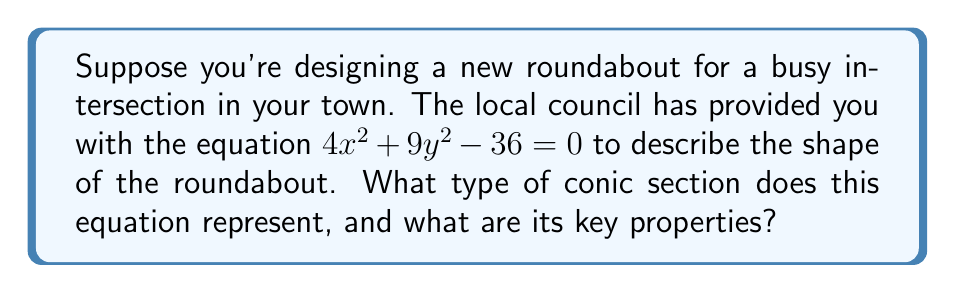Could you help me with this problem? Let's approach this step-by-step:

1) The general form of a conic section is:
   $Ax^2 + Bxy + Cy^2 + Dx + Ey + F = 0$

2) In our equation $4x^2 + 9y^2 - 36 = 0$, we can identify:
   $A = 4$, $C = 9$, $F = -36$, and $B = D = E = 0$

3) To determine the type of conic section, we need to look at the coefficients of $x^2$ and $y^2$:
   - Both coefficients are positive and non-zero
   - There's no $xy$ term (B = 0)
   - The constant term is on the other side of the equation

   These characteristics indicate that this is an ellipse.

4) To find the properties, let's rearrange the equation:
   $\frac{x^2}{9} + \frac{y^2}{4} = 1$

5) This is the standard form of an ellipse: $\frac{x^2}{a^2} + \frac{y^2}{b^2} = 1$
   Where $a$ and $b$ are the lengths of the semi-major and semi-minor axes.

6) From our equation:
   $a^2 = 9$, so $a = 3$
   $b^2 = 4$, so $b = 2$

7) Key properties:
   - Center: (0, 0)
   - Semi-major axis: 3 units (along x-axis)
   - Semi-minor axis: 2 units (along y-axis)
   - Eccentricity: $e = \sqrt{1 - \frac{b^2}{a^2}} = \sqrt{1 - \frac{4}{9}} = \frac{\sqrt{5}}{3}$
Answer: Ellipse; center (0,0), semi-major axis 3, semi-minor axis 2, eccentricity $\frac{\sqrt{5}}{3}$ 